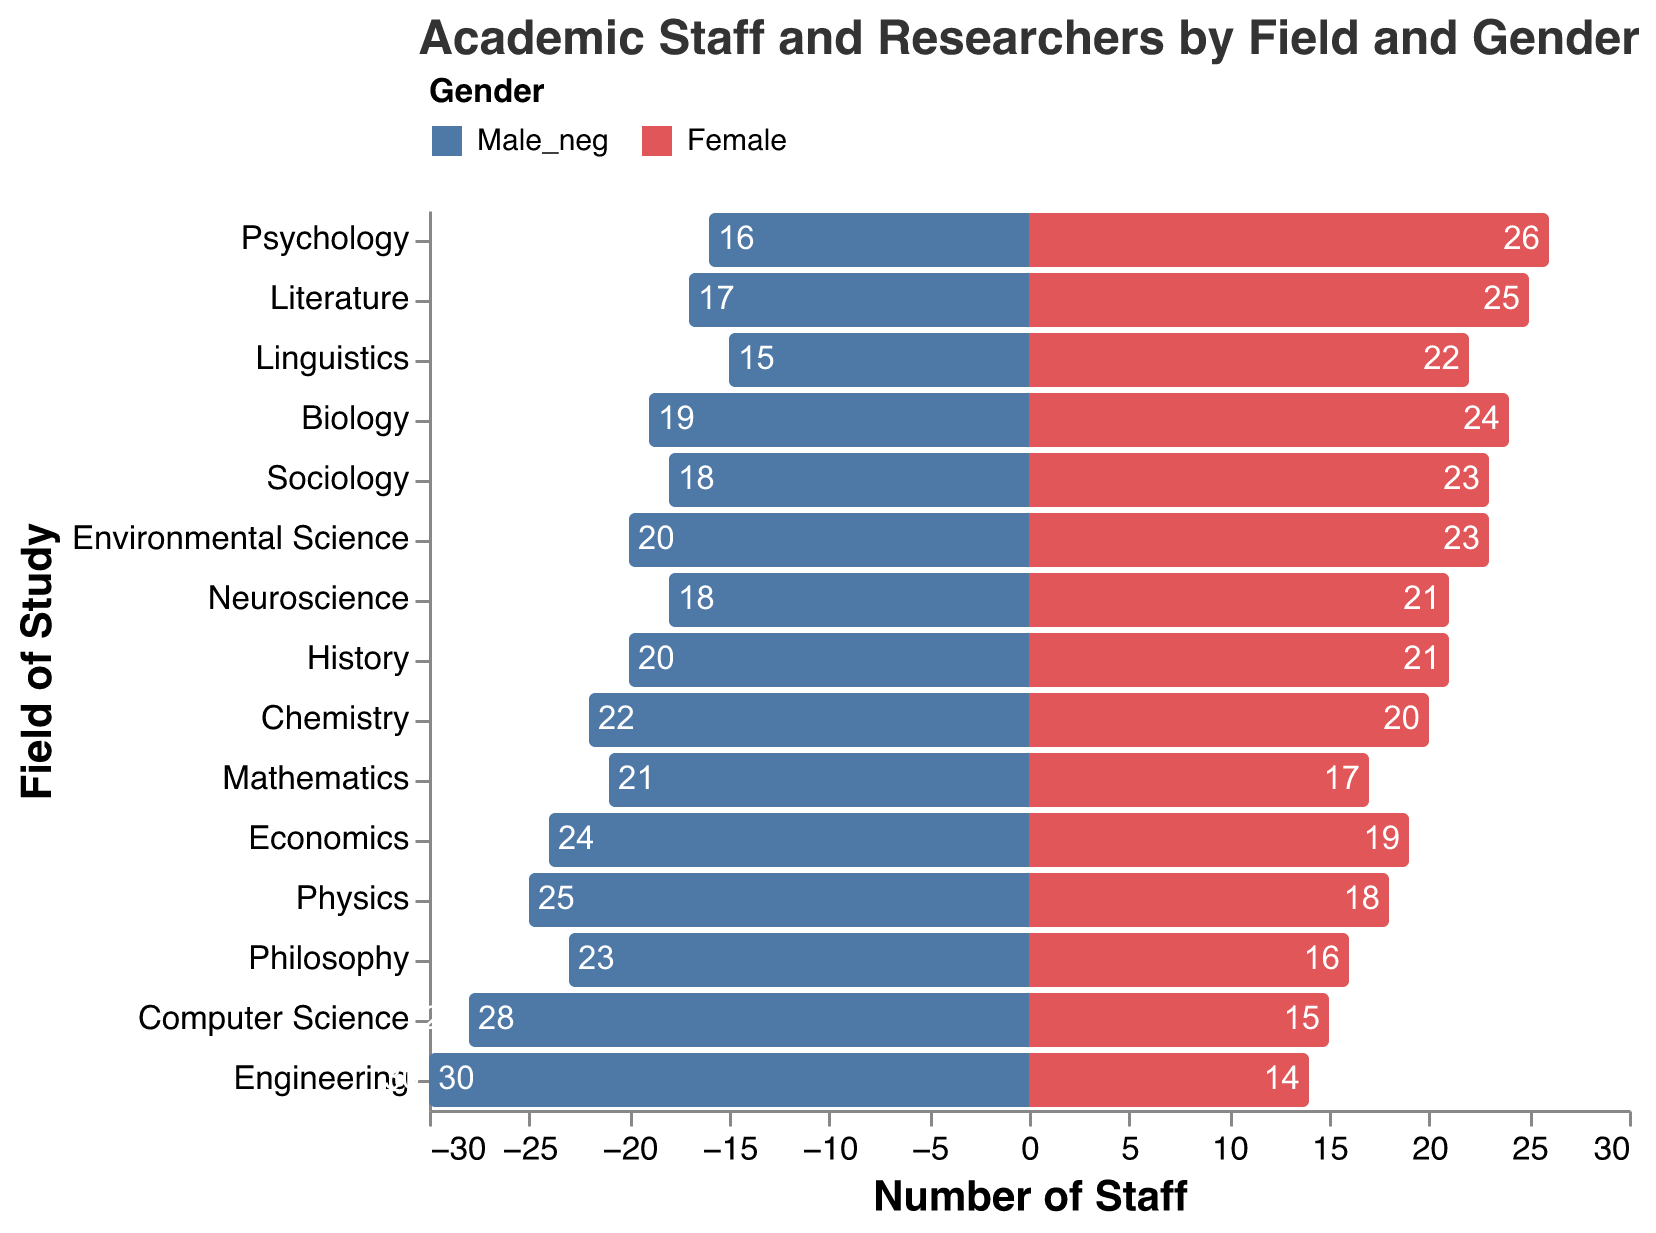What's the title of the figure? The title of the figure is displayed at the top, which says "Academic Staff and Researchers by Field and Gender".
Answer: Academic Staff and Researchers by Field and Gender How many fields have more female staff than male staff? Count the fields where the pink bar representing females is longer than the blue bar representing males.
Answer: 8 Which field has the highest number of male staff? Look for the longest blue bar and check its corresponding field.
Answer: Engineering What's the difference in the number of male and female staff in Computer Science? Computer Science has 28 male and 15 female staff. The difference is calculated as 28 - 15.
Answer: 13 Which field has an equal number of male and female staff? Find the field where blue and pink bars are of the same length.
Answer: None What's the total number of staff in Mathematics? Add the number of male and female staff in Mathematics, which are 21 and 17 respectively, so 21 + 17.
Answer: 38 In which field is the gender disparity most pronounced? Find the field where the difference between lengths of the blue and pink bars is the largest. Engineering has the largest disparity (30 males, 14 females).
Answer: Engineering What is the combined total number of male staff in Physics and Chemistry? Add the number of male staff in Physics and Chemistry: 25 (Physics) + 22 (Chemistry).
Answer: 47 Which field has the highest combined total number of staff? Sum the male and female staff for each field and identify the highest value. Psychology has the highest combined total: 16 males + 26 females = 42.
Answer: Psychology How many fields have a male-to-female ratio greater than 1? Count the fields where the number of male staff is greater than the number of female staff.
Answer: 8 